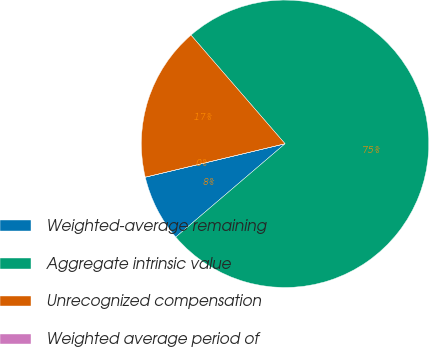Convert chart. <chart><loc_0><loc_0><loc_500><loc_500><pie_chart><fcel>Weighted-average remaining<fcel>Aggregate intrinsic value<fcel>Unrecognized compensation<fcel>Weighted average period of<nl><fcel>7.51%<fcel>75.11%<fcel>17.38%<fcel>0.0%<nl></chart> 